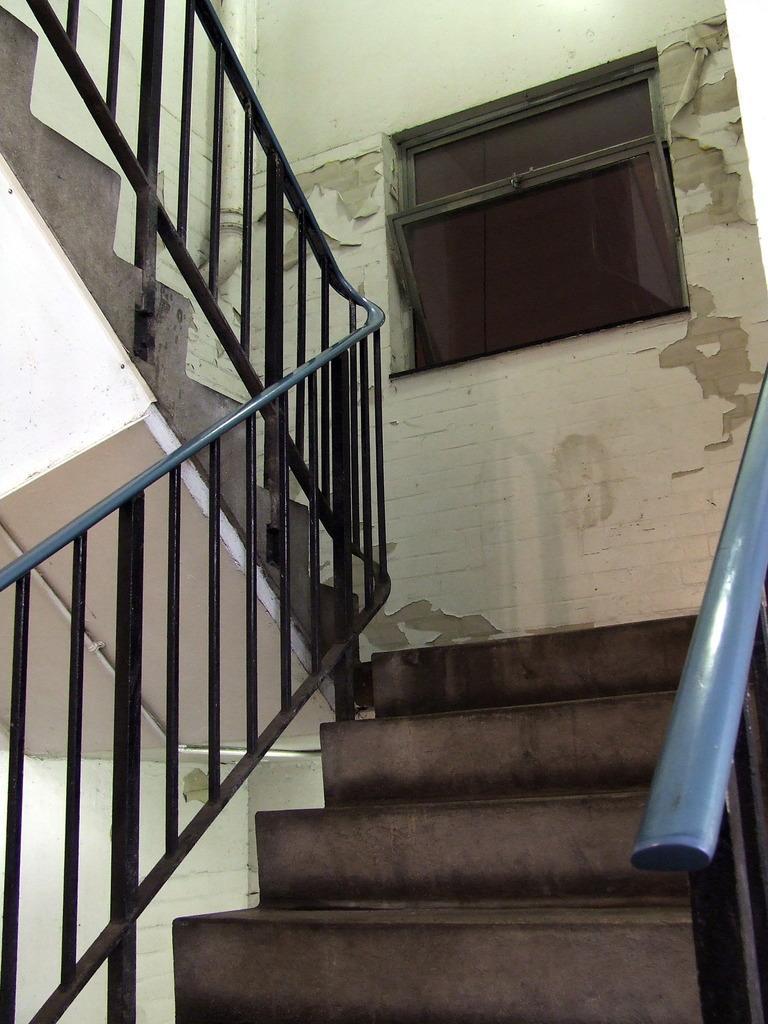Could you give a brief overview of what you see in this image? In this image there is a staircase. Background there is a wall having window to it. 